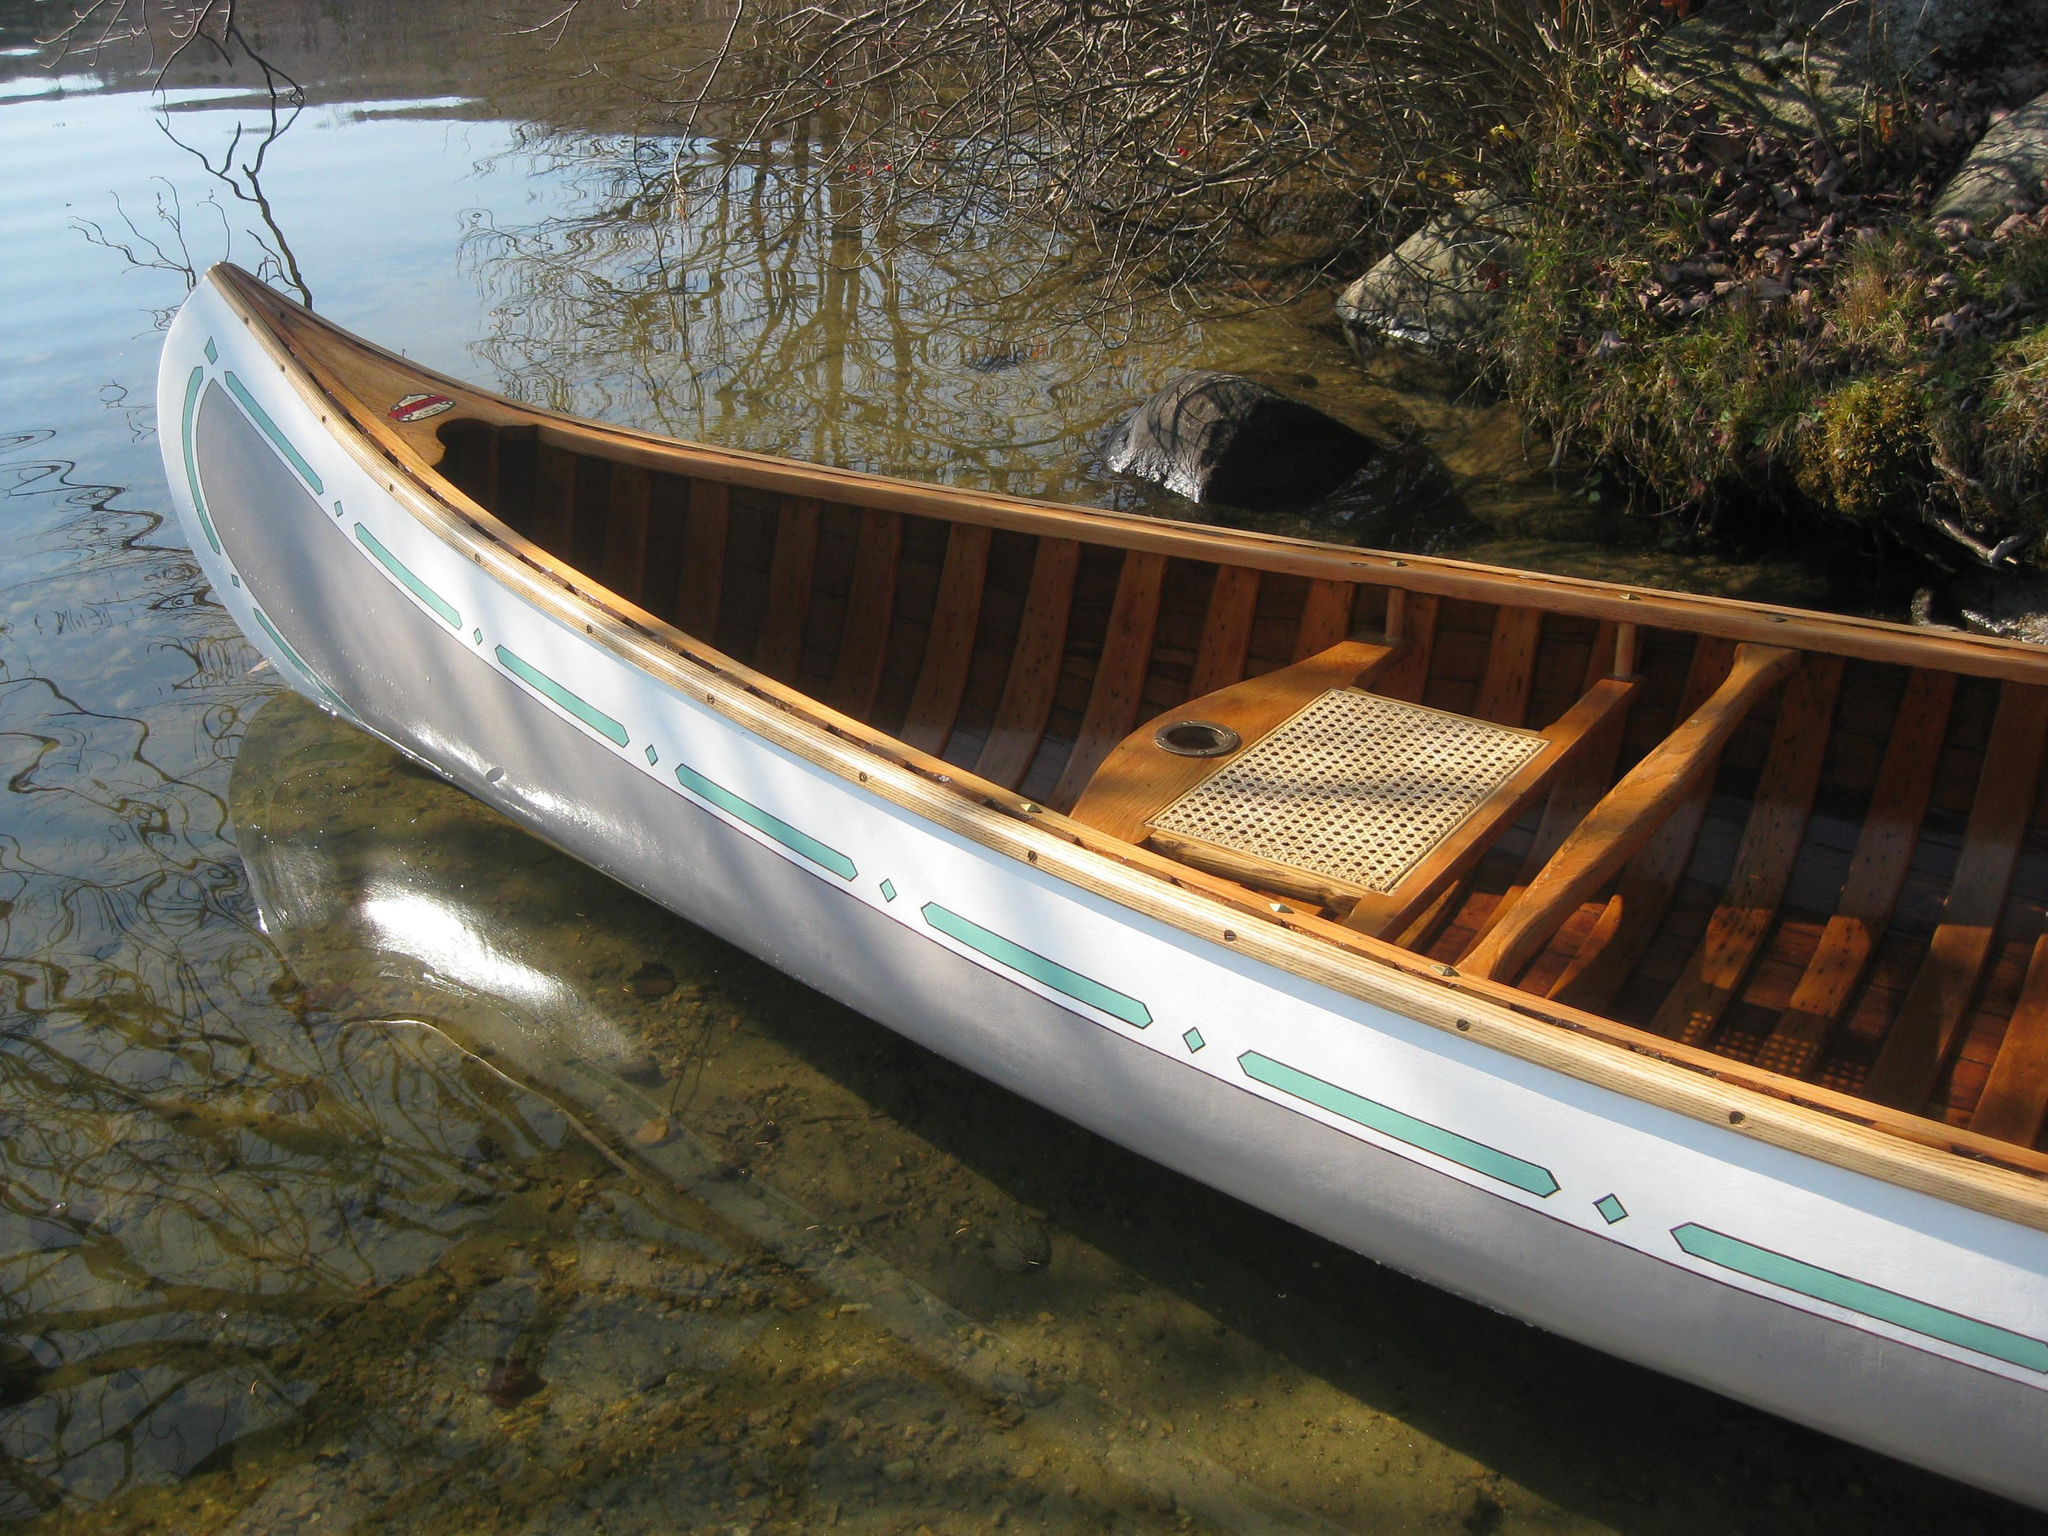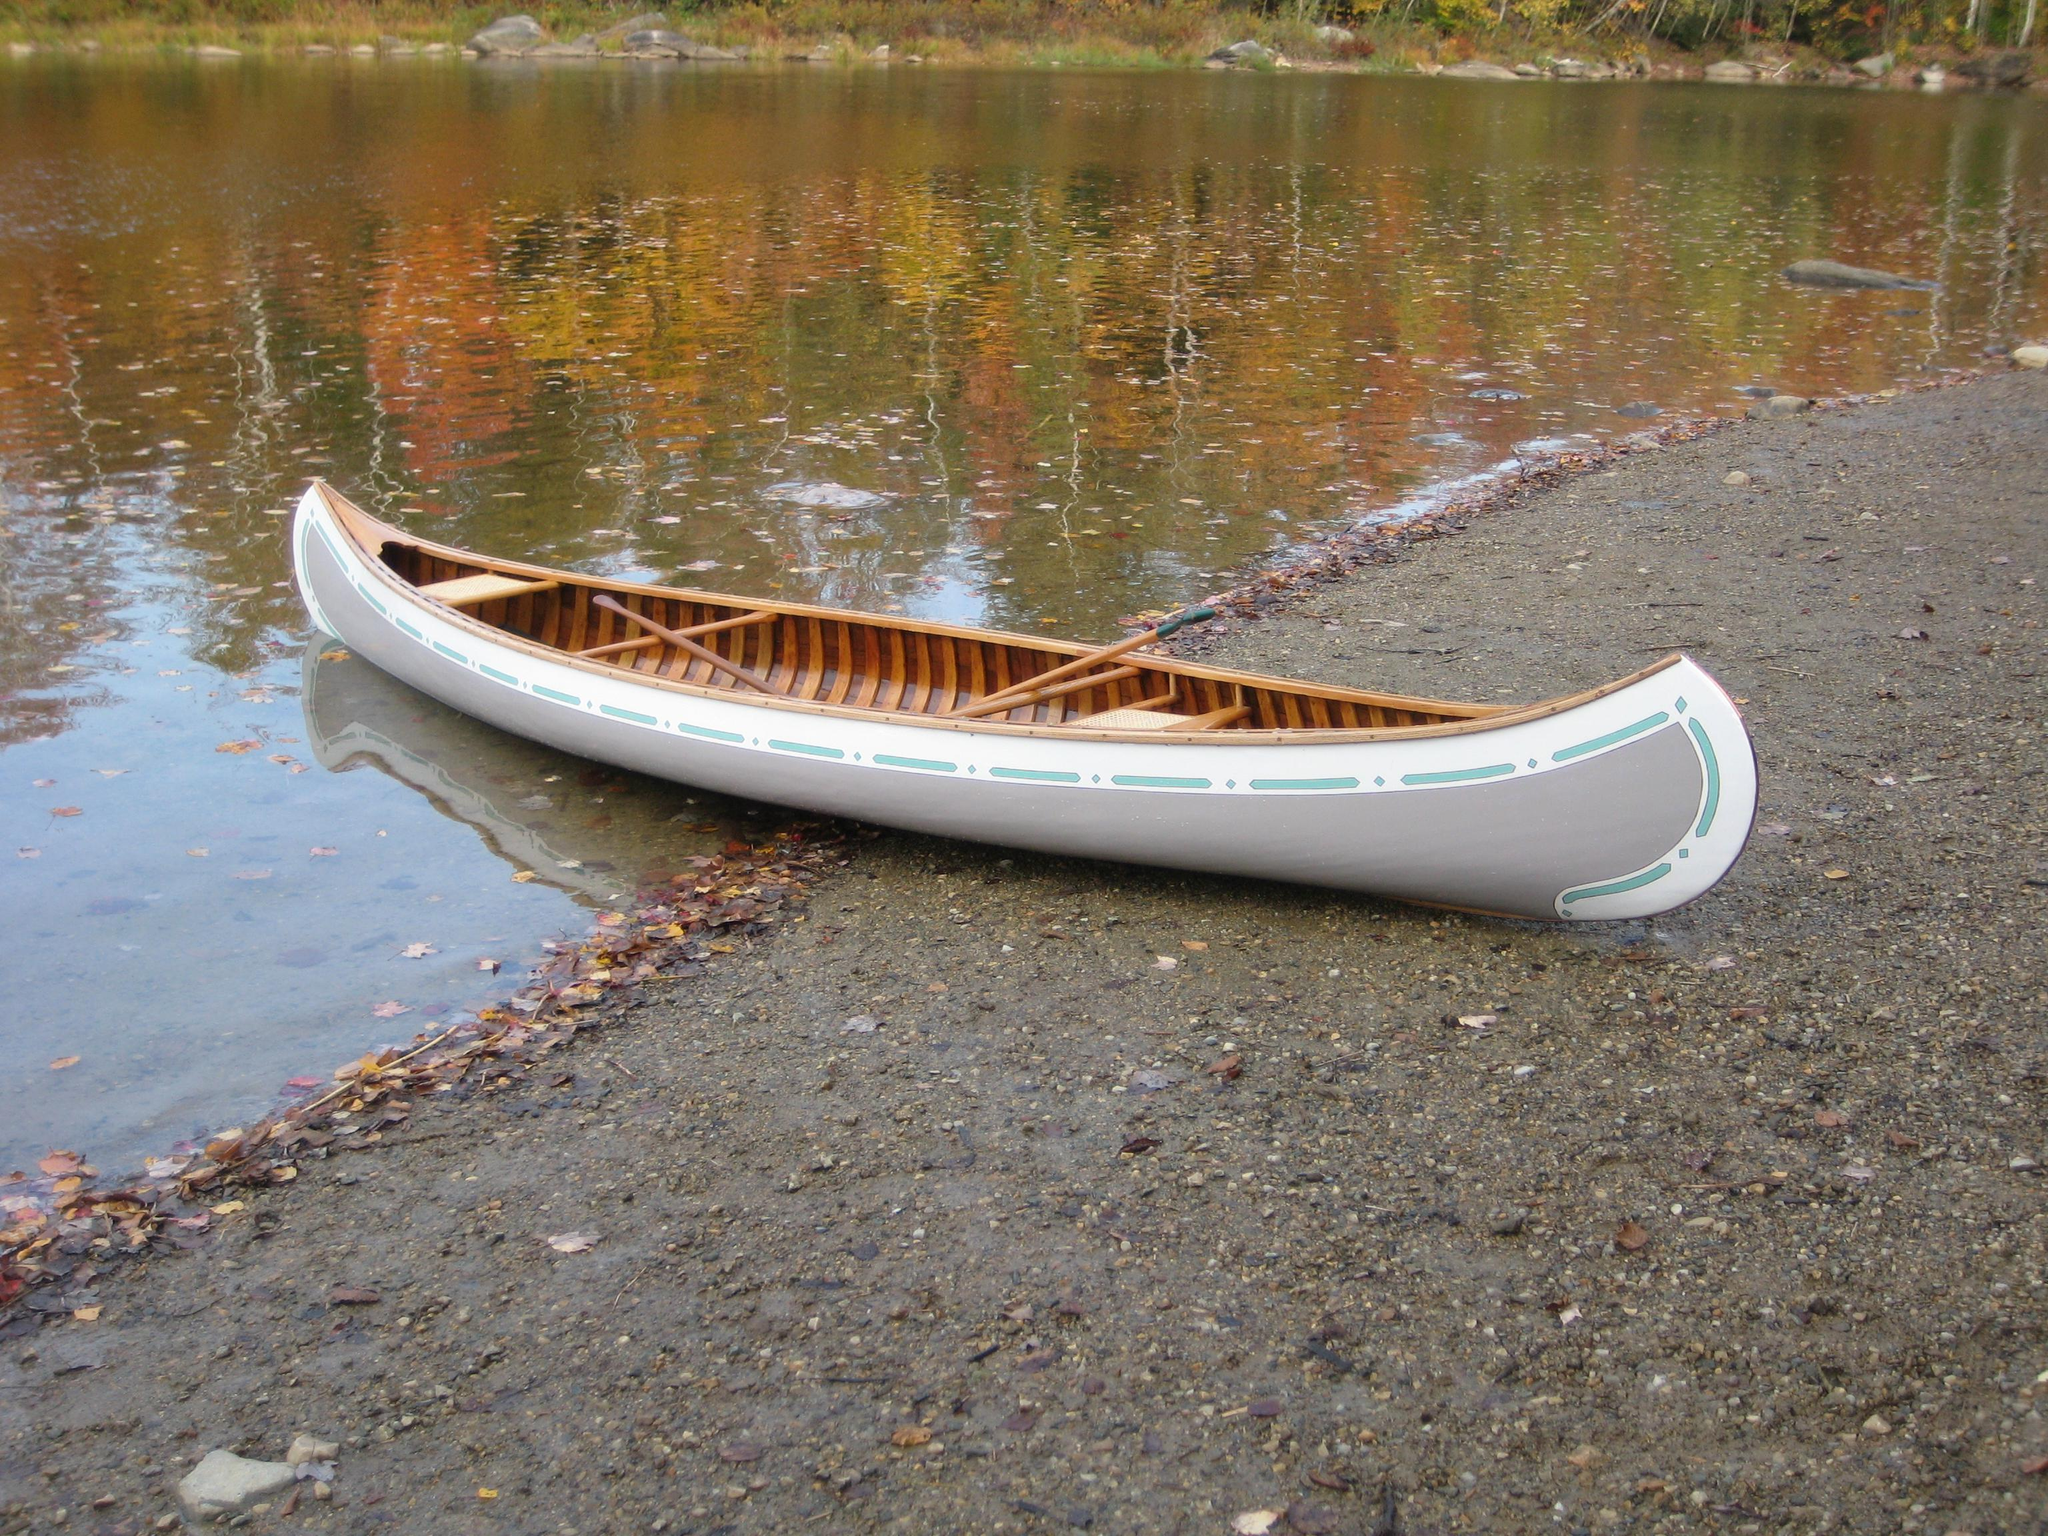The first image is the image on the left, the second image is the image on the right. Examine the images to the left and right. Is the description "Both canoes are outside and on dry land." accurate? Answer yes or no. No. The first image is the image on the left, the second image is the image on the right. Assess this claim about the two images: "The right image shows a green canoe lying on grass.". Correct or not? Answer yes or no. No. 